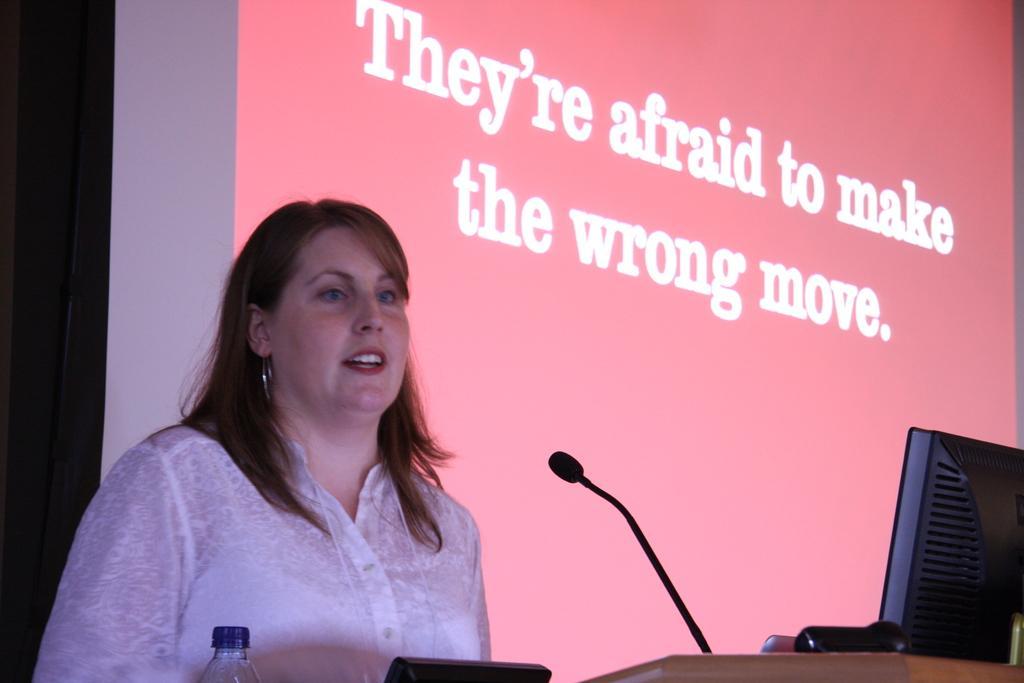Describe this image in one or two sentences. There is one women standing on the left side of this image is wearing a white color dress. There is a bottle ,Mic, and a desktop is present at the bottom of this image. There is a screen in the background and there is some text written on it. 